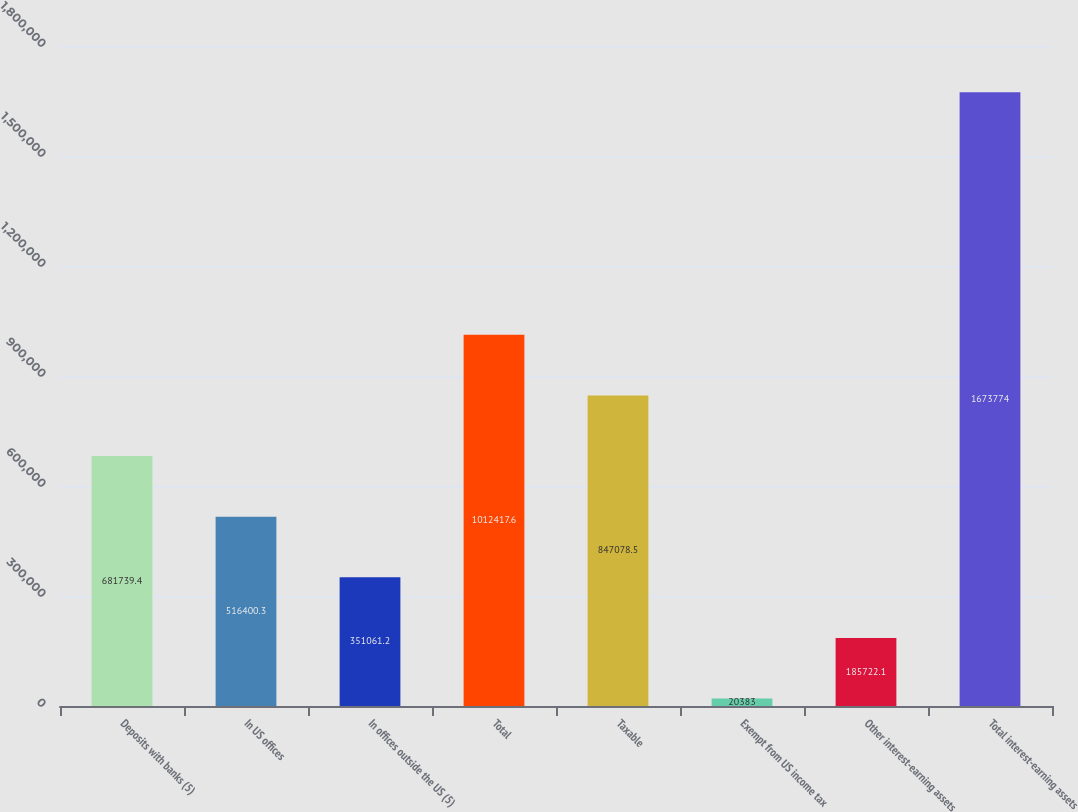<chart> <loc_0><loc_0><loc_500><loc_500><bar_chart><fcel>Deposits with banks (5)<fcel>In US offices<fcel>In offices outside the US (5)<fcel>Total<fcel>Taxable<fcel>Exempt from US income tax<fcel>Other interest-earning assets<fcel>Total interest-earning assets<nl><fcel>681739<fcel>516400<fcel>351061<fcel>1.01242e+06<fcel>847078<fcel>20383<fcel>185722<fcel>1.67377e+06<nl></chart> 